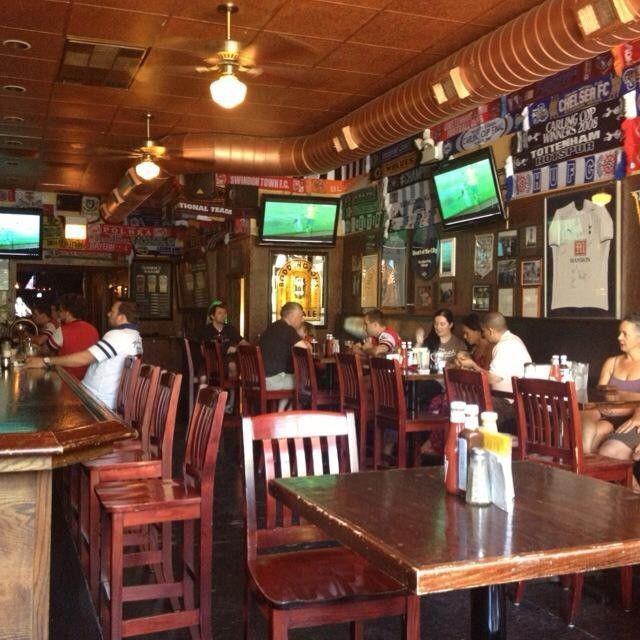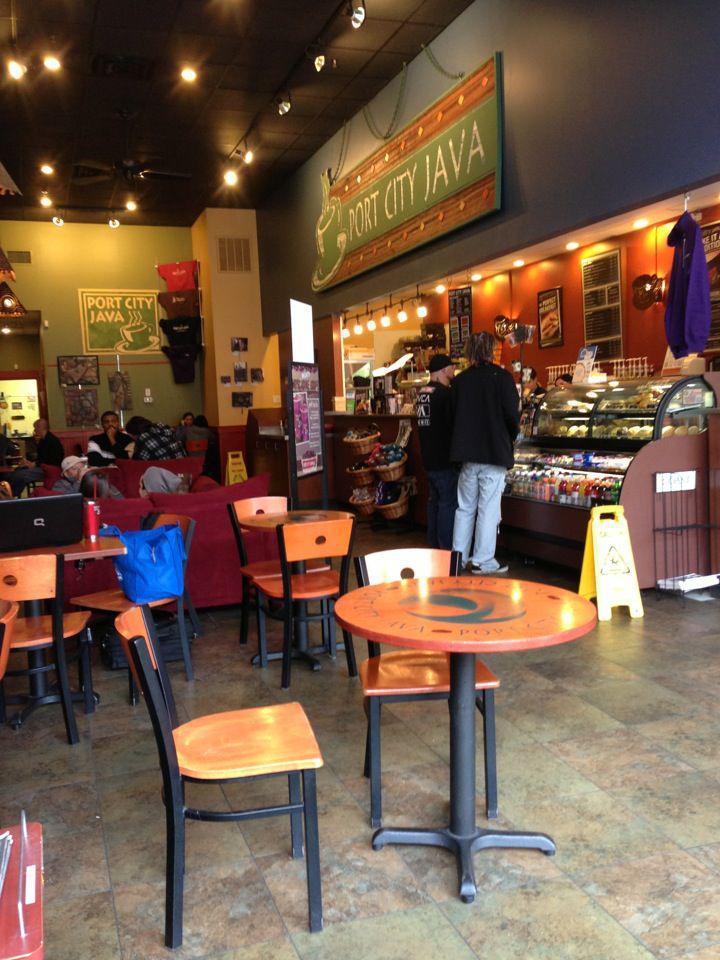The first image is the image on the left, the second image is the image on the right. For the images displayed, is the sentence "The right image shows tables and chairs for patrons, and the left image shows multiple people with backs to the camera in the foreground." factually correct? Answer yes or no. No. The first image is the image on the left, the second image is the image on the right. Assess this claim about the two images: "There is an employee of the business in one of the images.". Correct or not? Answer yes or no. No. 